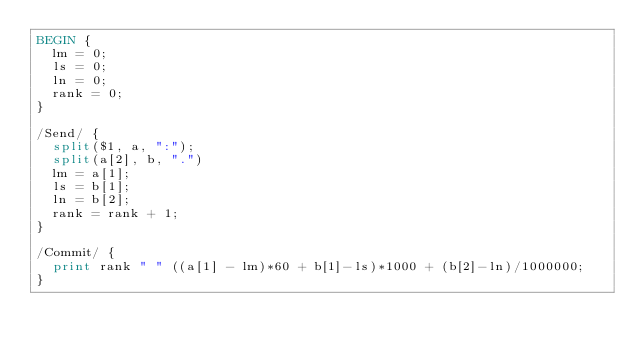<code> <loc_0><loc_0><loc_500><loc_500><_Awk_>BEGIN {
  lm = 0;
  ls = 0;
  ln = 0;
  rank = 0;
}

/Send/ {
  split($1, a, ":");
  split(a[2], b, ".")
  lm = a[1];
  ls = b[1];
  ln = b[2];
  rank = rank + 1;
}

/Commit/ {
  print rank " " ((a[1] - lm)*60 + b[1]-ls)*1000 + (b[2]-ln)/1000000; 
}
</code> 